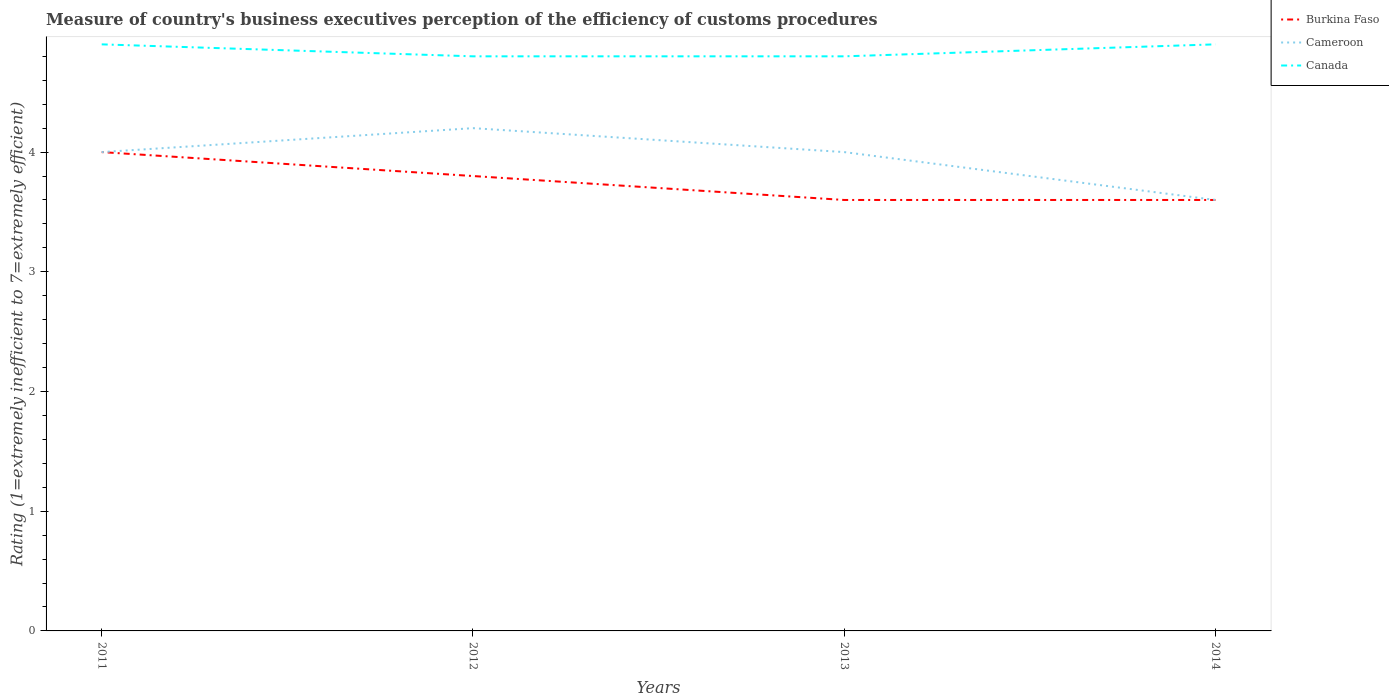Does the line corresponding to Cameroon intersect with the line corresponding to Burkina Faso?
Offer a very short reply. Yes. What is the difference between the highest and the second highest rating of the efficiency of customs procedure in Canada?
Make the answer very short. 0.1. Are the values on the major ticks of Y-axis written in scientific E-notation?
Your answer should be very brief. No. Where does the legend appear in the graph?
Provide a succinct answer. Top right. How are the legend labels stacked?
Your answer should be compact. Vertical. What is the title of the graph?
Provide a succinct answer. Measure of country's business executives perception of the efficiency of customs procedures. Does "Tunisia" appear as one of the legend labels in the graph?
Provide a short and direct response. No. What is the label or title of the X-axis?
Provide a succinct answer. Years. What is the label or title of the Y-axis?
Ensure brevity in your answer.  Rating (1=extremely inefficient to 7=extremely efficient). What is the Rating (1=extremely inefficient to 7=extremely efficient) in Burkina Faso in 2011?
Offer a terse response. 4. What is the Rating (1=extremely inefficient to 7=extremely efficient) in Cameroon in 2011?
Keep it short and to the point. 4. What is the Rating (1=extremely inefficient to 7=extremely efficient) of Canada in 2011?
Offer a terse response. 4.9. What is the Rating (1=extremely inefficient to 7=extremely efficient) in Cameroon in 2012?
Provide a short and direct response. 4.2. What is the Rating (1=extremely inefficient to 7=extremely efficient) of Canada in 2012?
Provide a succinct answer. 4.8. What is the Rating (1=extremely inefficient to 7=extremely efficient) in Burkina Faso in 2013?
Your answer should be compact. 3.6. Across all years, what is the maximum Rating (1=extremely inefficient to 7=extremely efficient) in Burkina Faso?
Your answer should be very brief. 4. Across all years, what is the maximum Rating (1=extremely inefficient to 7=extremely efficient) in Cameroon?
Provide a succinct answer. 4.2. Across all years, what is the maximum Rating (1=extremely inefficient to 7=extremely efficient) of Canada?
Your answer should be compact. 4.9. Across all years, what is the minimum Rating (1=extremely inefficient to 7=extremely efficient) of Burkina Faso?
Your answer should be compact. 3.6. Across all years, what is the minimum Rating (1=extremely inefficient to 7=extremely efficient) in Cameroon?
Offer a very short reply. 3.6. What is the total Rating (1=extremely inefficient to 7=extremely efficient) of Cameroon in the graph?
Offer a very short reply. 15.8. What is the total Rating (1=extremely inefficient to 7=extremely efficient) of Canada in the graph?
Ensure brevity in your answer.  19.4. What is the difference between the Rating (1=extremely inefficient to 7=extremely efficient) of Cameroon in 2011 and that in 2012?
Make the answer very short. -0.2. What is the difference between the Rating (1=extremely inefficient to 7=extremely efficient) in Burkina Faso in 2011 and that in 2014?
Keep it short and to the point. 0.4. What is the difference between the Rating (1=extremely inefficient to 7=extremely efficient) in Cameroon in 2011 and that in 2014?
Provide a short and direct response. 0.4. What is the difference between the Rating (1=extremely inefficient to 7=extremely efficient) in Burkina Faso in 2012 and that in 2013?
Make the answer very short. 0.2. What is the difference between the Rating (1=extremely inefficient to 7=extremely efficient) of Cameroon in 2012 and that in 2014?
Ensure brevity in your answer.  0.6. What is the difference between the Rating (1=extremely inefficient to 7=extremely efficient) of Canada in 2013 and that in 2014?
Offer a terse response. -0.1. What is the difference between the Rating (1=extremely inefficient to 7=extremely efficient) of Burkina Faso in 2011 and the Rating (1=extremely inefficient to 7=extremely efficient) of Cameroon in 2012?
Ensure brevity in your answer.  -0.2. What is the difference between the Rating (1=extremely inefficient to 7=extremely efficient) in Burkina Faso in 2011 and the Rating (1=extremely inefficient to 7=extremely efficient) in Canada in 2012?
Give a very brief answer. -0.8. What is the difference between the Rating (1=extremely inefficient to 7=extremely efficient) of Cameroon in 2011 and the Rating (1=extremely inefficient to 7=extremely efficient) of Canada in 2013?
Provide a succinct answer. -0.8. What is the difference between the Rating (1=extremely inefficient to 7=extremely efficient) in Burkina Faso in 2011 and the Rating (1=extremely inefficient to 7=extremely efficient) in Cameroon in 2014?
Your answer should be very brief. 0.4. What is the difference between the Rating (1=extremely inefficient to 7=extremely efficient) in Burkina Faso in 2012 and the Rating (1=extremely inefficient to 7=extremely efficient) in Cameroon in 2013?
Provide a short and direct response. -0.2. What is the difference between the Rating (1=extremely inefficient to 7=extremely efficient) of Burkina Faso in 2012 and the Rating (1=extremely inefficient to 7=extremely efficient) of Cameroon in 2014?
Your answer should be very brief. 0.2. What is the difference between the Rating (1=extremely inefficient to 7=extremely efficient) in Cameroon in 2012 and the Rating (1=extremely inefficient to 7=extremely efficient) in Canada in 2014?
Your response must be concise. -0.7. What is the difference between the Rating (1=extremely inefficient to 7=extremely efficient) in Burkina Faso in 2013 and the Rating (1=extremely inefficient to 7=extremely efficient) in Cameroon in 2014?
Give a very brief answer. 0. What is the difference between the Rating (1=extremely inefficient to 7=extremely efficient) in Burkina Faso in 2013 and the Rating (1=extremely inefficient to 7=extremely efficient) in Canada in 2014?
Offer a very short reply. -1.3. What is the average Rating (1=extremely inefficient to 7=extremely efficient) in Burkina Faso per year?
Keep it short and to the point. 3.75. What is the average Rating (1=extremely inefficient to 7=extremely efficient) in Cameroon per year?
Make the answer very short. 3.95. What is the average Rating (1=extremely inefficient to 7=extremely efficient) of Canada per year?
Provide a short and direct response. 4.85. In the year 2011, what is the difference between the Rating (1=extremely inefficient to 7=extremely efficient) in Burkina Faso and Rating (1=extremely inefficient to 7=extremely efficient) in Canada?
Ensure brevity in your answer.  -0.9. In the year 2011, what is the difference between the Rating (1=extremely inefficient to 7=extremely efficient) of Cameroon and Rating (1=extremely inefficient to 7=extremely efficient) of Canada?
Your response must be concise. -0.9. In the year 2012, what is the difference between the Rating (1=extremely inefficient to 7=extremely efficient) of Burkina Faso and Rating (1=extremely inefficient to 7=extremely efficient) of Canada?
Keep it short and to the point. -1. In the year 2012, what is the difference between the Rating (1=extremely inefficient to 7=extremely efficient) of Cameroon and Rating (1=extremely inefficient to 7=extremely efficient) of Canada?
Provide a succinct answer. -0.6. In the year 2013, what is the difference between the Rating (1=extremely inefficient to 7=extremely efficient) in Burkina Faso and Rating (1=extremely inefficient to 7=extremely efficient) in Canada?
Provide a succinct answer. -1.2. In the year 2013, what is the difference between the Rating (1=extremely inefficient to 7=extremely efficient) of Cameroon and Rating (1=extremely inefficient to 7=extremely efficient) of Canada?
Make the answer very short. -0.8. In the year 2014, what is the difference between the Rating (1=extremely inefficient to 7=extremely efficient) of Burkina Faso and Rating (1=extremely inefficient to 7=extremely efficient) of Cameroon?
Provide a short and direct response. 0. In the year 2014, what is the difference between the Rating (1=extremely inefficient to 7=extremely efficient) of Burkina Faso and Rating (1=extremely inefficient to 7=extremely efficient) of Canada?
Offer a terse response. -1.3. In the year 2014, what is the difference between the Rating (1=extremely inefficient to 7=extremely efficient) in Cameroon and Rating (1=extremely inefficient to 7=extremely efficient) in Canada?
Offer a terse response. -1.3. What is the ratio of the Rating (1=extremely inefficient to 7=extremely efficient) in Burkina Faso in 2011 to that in 2012?
Keep it short and to the point. 1.05. What is the ratio of the Rating (1=extremely inefficient to 7=extremely efficient) in Canada in 2011 to that in 2012?
Keep it short and to the point. 1.02. What is the ratio of the Rating (1=extremely inefficient to 7=extremely efficient) in Cameroon in 2011 to that in 2013?
Give a very brief answer. 1. What is the ratio of the Rating (1=extremely inefficient to 7=extremely efficient) in Canada in 2011 to that in 2013?
Your answer should be very brief. 1.02. What is the ratio of the Rating (1=extremely inefficient to 7=extremely efficient) of Cameroon in 2011 to that in 2014?
Give a very brief answer. 1.11. What is the ratio of the Rating (1=extremely inefficient to 7=extremely efficient) in Canada in 2011 to that in 2014?
Your answer should be very brief. 1. What is the ratio of the Rating (1=extremely inefficient to 7=extremely efficient) of Burkina Faso in 2012 to that in 2013?
Provide a succinct answer. 1.06. What is the ratio of the Rating (1=extremely inefficient to 7=extremely efficient) in Burkina Faso in 2012 to that in 2014?
Ensure brevity in your answer.  1.06. What is the ratio of the Rating (1=extremely inefficient to 7=extremely efficient) in Cameroon in 2012 to that in 2014?
Provide a succinct answer. 1.17. What is the ratio of the Rating (1=extremely inefficient to 7=extremely efficient) in Canada in 2012 to that in 2014?
Give a very brief answer. 0.98. What is the ratio of the Rating (1=extremely inefficient to 7=extremely efficient) in Canada in 2013 to that in 2014?
Provide a short and direct response. 0.98. What is the difference between the highest and the second highest Rating (1=extremely inefficient to 7=extremely efficient) in Burkina Faso?
Your answer should be compact. 0.2. What is the difference between the highest and the lowest Rating (1=extremely inefficient to 7=extremely efficient) in Cameroon?
Give a very brief answer. 0.6. What is the difference between the highest and the lowest Rating (1=extremely inefficient to 7=extremely efficient) of Canada?
Provide a short and direct response. 0.1. 